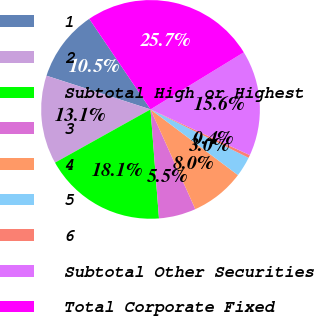Convert chart to OTSL. <chart><loc_0><loc_0><loc_500><loc_500><pie_chart><fcel>1<fcel>2<fcel>Subtotal High or Highest<fcel>3<fcel>4<fcel>5<fcel>6<fcel>Subtotal Other Securities<fcel>Total Corporate Fixed<nl><fcel>10.55%<fcel>13.08%<fcel>18.14%<fcel>5.49%<fcel>8.02%<fcel>2.96%<fcel>0.43%<fcel>15.61%<fcel>25.73%<nl></chart> 